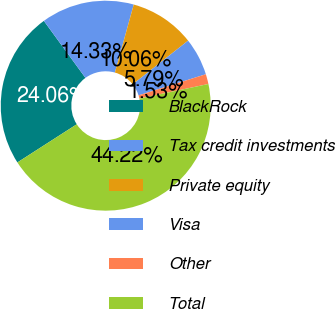Convert chart to OTSL. <chart><loc_0><loc_0><loc_500><loc_500><pie_chart><fcel>BlackRock<fcel>Tax credit investments<fcel>Private equity<fcel>Visa<fcel>Other<fcel>Total<nl><fcel>24.06%<fcel>14.33%<fcel>10.06%<fcel>5.79%<fcel>1.53%<fcel>44.22%<nl></chart> 